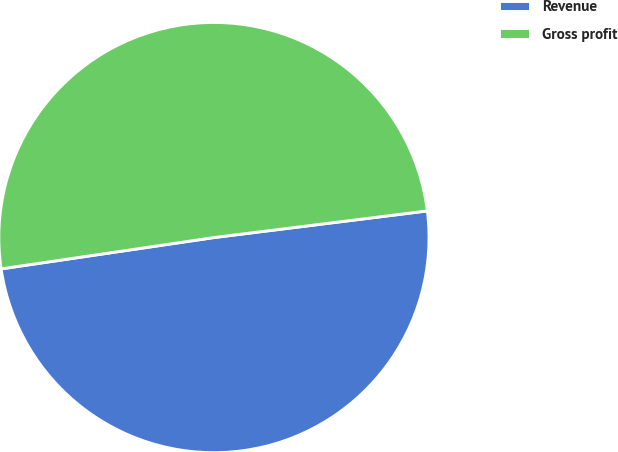<chart> <loc_0><loc_0><loc_500><loc_500><pie_chart><fcel>Revenue<fcel>Gross profit<nl><fcel>49.65%<fcel>50.35%<nl></chart> 